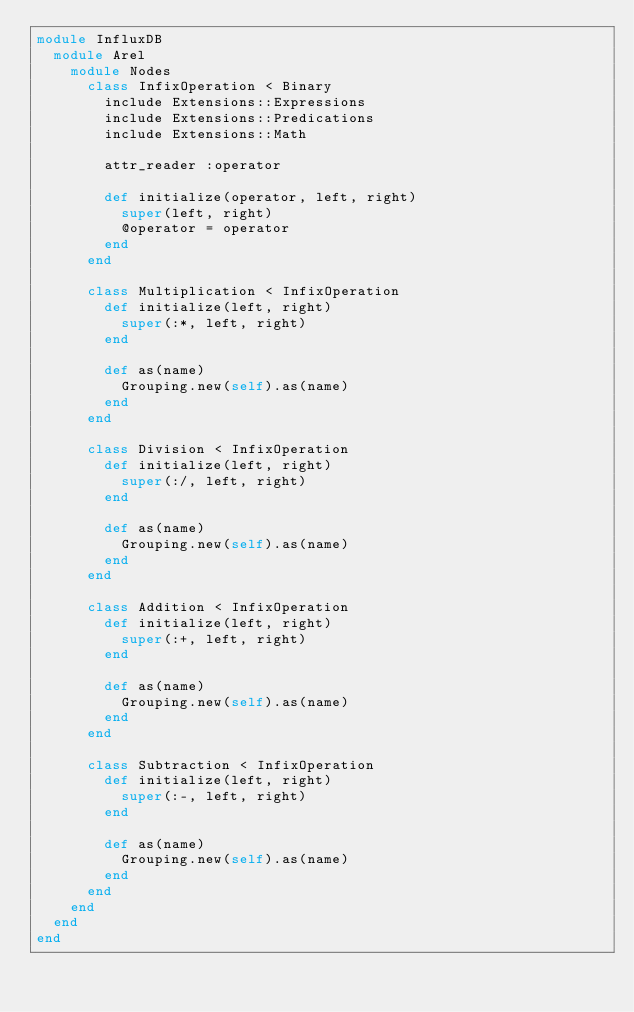Convert code to text. <code><loc_0><loc_0><loc_500><loc_500><_Ruby_>module InfluxDB
  module Arel
    module Nodes
      class InfixOperation < Binary
        include Extensions::Expressions
        include Extensions::Predications
        include Extensions::Math

        attr_reader :operator

        def initialize(operator, left, right)
          super(left, right)
          @operator = operator
        end
      end

      class Multiplication < InfixOperation
        def initialize(left, right)
          super(:*, left, right)
        end

        def as(name)
          Grouping.new(self).as(name)
        end
      end

      class Division < InfixOperation
        def initialize(left, right)
          super(:/, left, right)
        end

        def as(name)
          Grouping.new(self).as(name)
        end
      end

      class Addition < InfixOperation
        def initialize(left, right)
          super(:+, left, right)
        end

        def as(name)
          Grouping.new(self).as(name)
        end
      end

      class Subtraction < InfixOperation
        def initialize(left, right)
          super(:-, left, right)
        end

        def as(name)
          Grouping.new(self).as(name)
        end
      end
    end
  end
end
</code> 